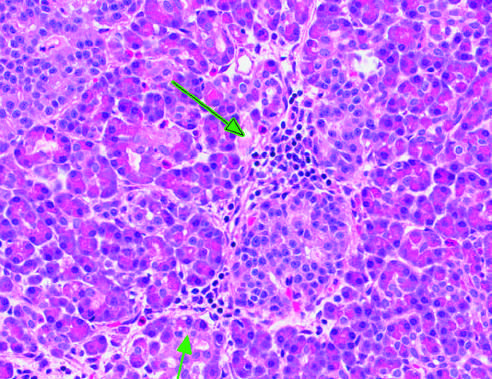re clusters of pigmented hepatocytes with eosinophilic cytoplasm essentially normal?
Answer the question using a single word or phrase. No 